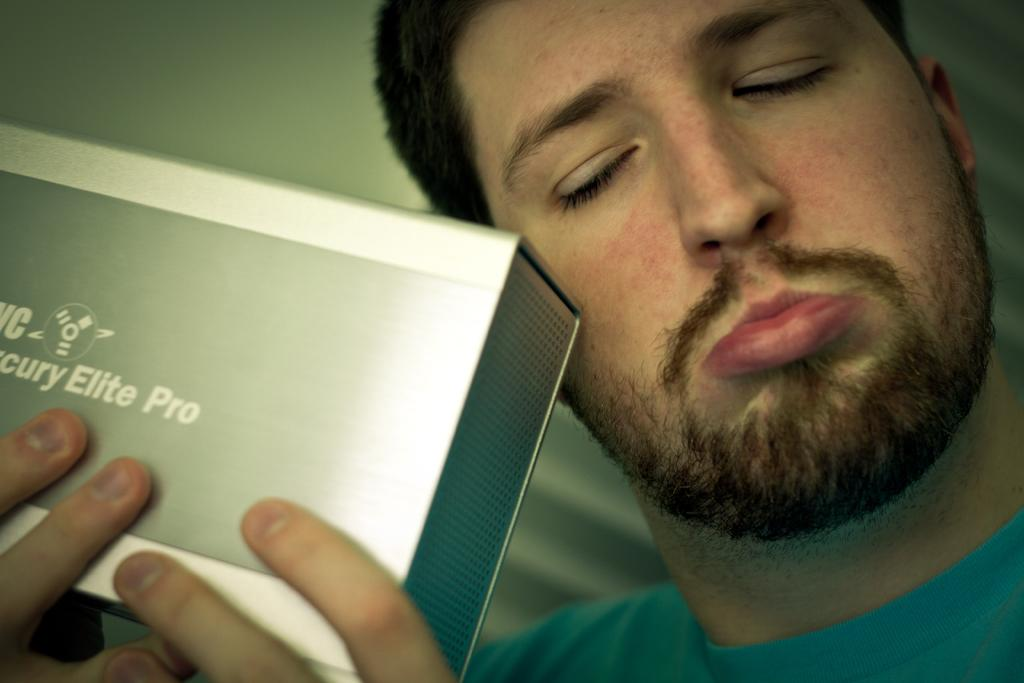What is present in the image? There is a man in the image. What is the man doing in the image? The man is holding an object. Can you describe the background of the image? The background of the image is blurred. What type of oil can be seen dripping from the man's chin in the image? There is no oil or any dripping substance visible on the man's chin in the image. 